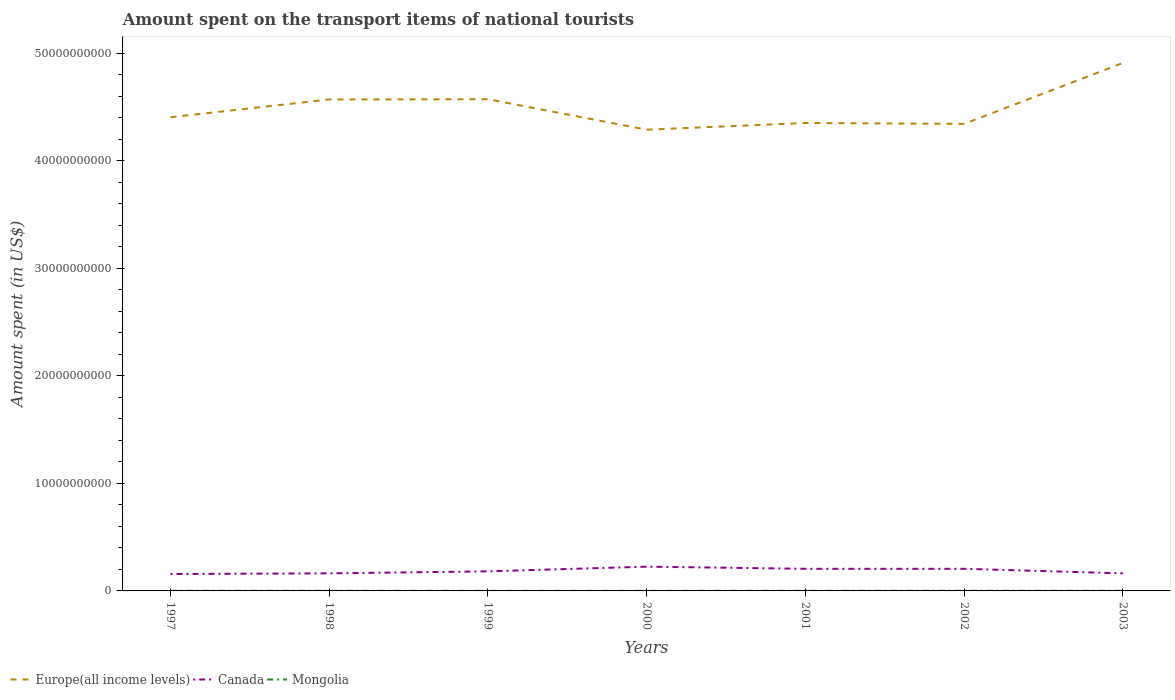Across all years, what is the maximum amount spent on the transport items of national tourists in Canada?
Offer a very short reply. 1.57e+09. In which year was the amount spent on the transport items of national tourists in Canada maximum?
Ensure brevity in your answer.  1997. What is the total amount spent on the transport items of national tourists in Mongolia in the graph?
Offer a very short reply. -3.00e+06. What is the difference between the highest and the second highest amount spent on the transport items of national tourists in Canada?
Keep it short and to the point. 6.86e+08. What is the difference between the highest and the lowest amount spent on the transport items of national tourists in Europe(all income levels)?
Offer a terse response. 3. Is the amount spent on the transport items of national tourists in Canada strictly greater than the amount spent on the transport items of national tourists in Europe(all income levels) over the years?
Provide a short and direct response. Yes. How many lines are there?
Offer a very short reply. 3. What is the difference between two consecutive major ticks on the Y-axis?
Ensure brevity in your answer.  1.00e+1. Are the values on the major ticks of Y-axis written in scientific E-notation?
Offer a terse response. No. Where does the legend appear in the graph?
Your answer should be compact. Bottom left. How many legend labels are there?
Your answer should be very brief. 3. What is the title of the graph?
Offer a very short reply. Amount spent on the transport items of national tourists. What is the label or title of the Y-axis?
Ensure brevity in your answer.  Amount spent (in US$). What is the Amount spent (in US$) of Europe(all income levels) in 1997?
Offer a very short reply. 4.41e+1. What is the Amount spent (in US$) of Canada in 1997?
Make the answer very short. 1.57e+09. What is the Amount spent (in US$) of Europe(all income levels) in 1998?
Give a very brief answer. 4.57e+1. What is the Amount spent (in US$) in Canada in 1998?
Your response must be concise. 1.64e+09. What is the Amount spent (in US$) in Mongolia in 1998?
Your response must be concise. 1.20e+07. What is the Amount spent (in US$) of Europe(all income levels) in 1999?
Ensure brevity in your answer.  4.57e+1. What is the Amount spent (in US$) of Canada in 1999?
Ensure brevity in your answer.  1.82e+09. What is the Amount spent (in US$) of Europe(all income levels) in 2000?
Provide a succinct answer. 4.29e+1. What is the Amount spent (in US$) of Canada in 2000?
Provide a short and direct response. 2.26e+09. What is the Amount spent (in US$) in Mongolia in 2000?
Give a very brief answer. 7.00e+06. What is the Amount spent (in US$) of Europe(all income levels) in 2001?
Offer a very short reply. 4.35e+1. What is the Amount spent (in US$) in Canada in 2001?
Offer a terse response. 2.06e+09. What is the Amount spent (in US$) in Europe(all income levels) in 2002?
Provide a short and direct response. 4.34e+1. What is the Amount spent (in US$) in Canada in 2002?
Make the answer very short. 2.06e+09. What is the Amount spent (in US$) of Mongolia in 2002?
Offer a terse response. 1.30e+07. What is the Amount spent (in US$) of Europe(all income levels) in 2003?
Provide a short and direct response. 4.91e+1. What is the Amount spent (in US$) of Canada in 2003?
Provide a short and direct response. 1.63e+09. What is the Amount spent (in US$) in Mongolia in 2003?
Ensure brevity in your answer.  1.10e+07. Across all years, what is the maximum Amount spent (in US$) in Europe(all income levels)?
Provide a short and direct response. 4.91e+1. Across all years, what is the maximum Amount spent (in US$) in Canada?
Give a very brief answer. 2.26e+09. Across all years, what is the maximum Amount spent (in US$) in Mongolia?
Your response must be concise. 1.30e+07. Across all years, what is the minimum Amount spent (in US$) of Europe(all income levels)?
Ensure brevity in your answer.  4.29e+1. Across all years, what is the minimum Amount spent (in US$) of Canada?
Offer a terse response. 1.57e+09. Across all years, what is the minimum Amount spent (in US$) of Mongolia?
Offer a very short reply. 7.00e+06. What is the total Amount spent (in US$) of Europe(all income levels) in the graph?
Your answer should be very brief. 3.14e+11. What is the total Amount spent (in US$) of Canada in the graph?
Your answer should be very brief. 1.30e+1. What is the total Amount spent (in US$) in Mongolia in the graph?
Provide a short and direct response. 7.20e+07. What is the difference between the Amount spent (in US$) in Europe(all income levels) in 1997 and that in 1998?
Provide a succinct answer. -1.66e+09. What is the difference between the Amount spent (in US$) of Canada in 1997 and that in 1998?
Keep it short and to the point. -6.40e+07. What is the difference between the Amount spent (in US$) of Europe(all income levels) in 1997 and that in 1999?
Make the answer very short. -1.68e+09. What is the difference between the Amount spent (in US$) in Canada in 1997 and that in 1999?
Give a very brief answer. -2.50e+08. What is the difference between the Amount spent (in US$) in Mongolia in 1997 and that in 1999?
Offer a terse response. 5.00e+06. What is the difference between the Amount spent (in US$) in Europe(all income levels) in 1997 and that in 2000?
Your response must be concise. 1.16e+09. What is the difference between the Amount spent (in US$) in Canada in 1997 and that in 2000?
Offer a very short reply. -6.86e+08. What is the difference between the Amount spent (in US$) in Mongolia in 1997 and that in 2000?
Give a very brief answer. 5.00e+06. What is the difference between the Amount spent (in US$) in Europe(all income levels) in 1997 and that in 2001?
Provide a succinct answer. 5.35e+08. What is the difference between the Amount spent (in US$) of Canada in 1997 and that in 2001?
Give a very brief answer. -4.86e+08. What is the difference between the Amount spent (in US$) in Mongolia in 1997 and that in 2001?
Keep it short and to the point. 2.00e+06. What is the difference between the Amount spent (in US$) in Europe(all income levels) in 1997 and that in 2002?
Make the answer very short. 6.14e+08. What is the difference between the Amount spent (in US$) of Canada in 1997 and that in 2002?
Your response must be concise. -4.86e+08. What is the difference between the Amount spent (in US$) of Mongolia in 1997 and that in 2002?
Keep it short and to the point. -1.00e+06. What is the difference between the Amount spent (in US$) in Europe(all income levels) in 1997 and that in 2003?
Keep it short and to the point. -5.05e+09. What is the difference between the Amount spent (in US$) of Canada in 1997 and that in 2003?
Provide a succinct answer. -6.30e+07. What is the difference between the Amount spent (in US$) of Mongolia in 1997 and that in 2003?
Your answer should be compact. 1.00e+06. What is the difference between the Amount spent (in US$) of Europe(all income levels) in 1998 and that in 1999?
Provide a succinct answer. -2.19e+07. What is the difference between the Amount spent (in US$) of Canada in 1998 and that in 1999?
Provide a succinct answer. -1.86e+08. What is the difference between the Amount spent (in US$) of Europe(all income levels) in 1998 and that in 2000?
Provide a short and direct response. 2.81e+09. What is the difference between the Amount spent (in US$) in Canada in 1998 and that in 2000?
Make the answer very short. -6.22e+08. What is the difference between the Amount spent (in US$) in Mongolia in 1998 and that in 2000?
Offer a terse response. 5.00e+06. What is the difference between the Amount spent (in US$) in Europe(all income levels) in 1998 and that in 2001?
Keep it short and to the point. 2.19e+09. What is the difference between the Amount spent (in US$) in Canada in 1998 and that in 2001?
Ensure brevity in your answer.  -4.22e+08. What is the difference between the Amount spent (in US$) of Mongolia in 1998 and that in 2001?
Your answer should be compact. 2.00e+06. What is the difference between the Amount spent (in US$) of Europe(all income levels) in 1998 and that in 2002?
Offer a terse response. 2.27e+09. What is the difference between the Amount spent (in US$) in Canada in 1998 and that in 2002?
Ensure brevity in your answer.  -4.22e+08. What is the difference between the Amount spent (in US$) of Mongolia in 1998 and that in 2002?
Make the answer very short. -1.00e+06. What is the difference between the Amount spent (in US$) of Europe(all income levels) in 1998 and that in 2003?
Provide a short and direct response. -3.39e+09. What is the difference between the Amount spent (in US$) of Mongolia in 1998 and that in 2003?
Your answer should be compact. 1.00e+06. What is the difference between the Amount spent (in US$) in Europe(all income levels) in 1999 and that in 2000?
Offer a very short reply. 2.83e+09. What is the difference between the Amount spent (in US$) in Canada in 1999 and that in 2000?
Provide a short and direct response. -4.36e+08. What is the difference between the Amount spent (in US$) in Mongolia in 1999 and that in 2000?
Provide a succinct answer. 0. What is the difference between the Amount spent (in US$) in Europe(all income levels) in 1999 and that in 2001?
Your answer should be compact. 2.21e+09. What is the difference between the Amount spent (in US$) of Canada in 1999 and that in 2001?
Ensure brevity in your answer.  -2.36e+08. What is the difference between the Amount spent (in US$) of Europe(all income levels) in 1999 and that in 2002?
Your answer should be very brief. 2.29e+09. What is the difference between the Amount spent (in US$) in Canada in 1999 and that in 2002?
Your answer should be compact. -2.36e+08. What is the difference between the Amount spent (in US$) of Mongolia in 1999 and that in 2002?
Make the answer very short. -6.00e+06. What is the difference between the Amount spent (in US$) of Europe(all income levels) in 1999 and that in 2003?
Make the answer very short. -3.37e+09. What is the difference between the Amount spent (in US$) of Canada in 1999 and that in 2003?
Provide a short and direct response. 1.87e+08. What is the difference between the Amount spent (in US$) of Europe(all income levels) in 2000 and that in 2001?
Your response must be concise. -6.21e+08. What is the difference between the Amount spent (in US$) of Mongolia in 2000 and that in 2001?
Ensure brevity in your answer.  -3.00e+06. What is the difference between the Amount spent (in US$) of Europe(all income levels) in 2000 and that in 2002?
Ensure brevity in your answer.  -5.42e+08. What is the difference between the Amount spent (in US$) of Mongolia in 2000 and that in 2002?
Your answer should be very brief. -6.00e+06. What is the difference between the Amount spent (in US$) in Europe(all income levels) in 2000 and that in 2003?
Make the answer very short. -6.21e+09. What is the difference between the Amount spent (in US$) of Canada in 2000 and that in 2003?
Ensure brevity in your answer.  6.23e+08. What is the difference between the Amount spent (in US$) in Europe(all income levels) in 2001 and that in 2002?
Provide a short and direct response. 7.86e+07. What is the difference between the Amount spent (in US$) in Canada in 2001 and that in 2002?
Ensure brevity in your answer.  0. What is the difference between the Amount spent (in US$) of Mongolia in 2001 and that in 2002?
Your answer should be compact. -3.00e+06. What is the difference between the Amount spent (in US$) in Europe(all income levels) in 2001 and that in 2003?
Your answer should be compact. -5.58e+09. What is the difference between the Amount spent (in US$) in Canada in 2001 and that in 2003?
Ensure brevity in your answer.  4.23e+08. What is the difference between the Amount spent (in US$) of Mongolia in 2001 and that in 2003?
Provide a succinct answer. -1.00e+06. What is the difference between the Amount spent (in US$) of Europe(all income levels) in 2002 and that in 2003?
Ensure brevity in your answer.  -5.66e+09. What is the difference between the Amount spent (in US$) of Canada in 2002 and that in 2003?
Offer a terse response. 4.23e+08. What is the difference between the Amount spent (in US$) of Europe(all income levels) in 1997 and the Amount spent (in US$) of Canada in 1998?
Provide a short and direct response. 4.24e+1. What is the difference between the Amount spent (in US$) of Europe(all income levels) in 1997 and the Amount spent (in US$) of Mongolia in 1998?
Keep it short and to the point. 4.40e+1. What is the difference between the Amount spent (in US$) of Canada in 1997 and the Amount spent (in US$) of Mongolia in 1998?
Provide a succinct answer. 1.56e+09. What is the difference between the Amount spent (in US$) in Europe(all income levels) in 1997 and the Amount spent (in US$) in Canada in 1999?
Keep it short and to the point. 4.22e+1. What is the difference between the Amount spent (in US$) of Europe(all income levels) in 1997 and the Amount spent (in US$) of Mongolia in 1999?
Provide a succinct answer. 4.41e+1. What is the difference between the Amount spent (in US$) in Canada in 1997 and the Amount spent (in US$) in Mongolia in 1999?
Your answer should be very brief. 1.56e+09. What is the difference between the Amount spent (in US$) in Europe(all income levels) in 1997 and the Amount spent (in US$) in Canada in 2000?
Offer a very short reply. 4.18e+1. What is the difference between the Amount spent (in US$) in Europe(all income levels) in 1997 and the Amount spent (in US$) in Mongolia in 2000?
Make the answer very short. 4.41e+1. What is the difference between the Amount spent (in US$) of Canada in 1997 and the Amount spent (in US$) of Mongolia in 2000?
Make the answer very short. 1.56e+09. What is the difference between the Amount spent (in US$) of Europe(all income levels) in 1997 and the Amount spent (in US$) of Canada in 2001?
Your response must be concise. 4.20e+1. What is the difference between the Amount spent (in US$) in Europe(all income levels) in 1997 and the Amount spent (in US$) in Mongolia in 2001?
Give a very brief answer. 4.40e+1. What is the difference between the Amount spent (in US$) in Canada in 1997 and the Amount spent (in US$) in Mongolia in 2001?
Make the answer very short. 1.56e+09. What is the difference between the Amount spent (in US$) of Europe(all income levels) in 1997 and the Amount spent (in US$) of Canada in 2002?
Your answer should be compact. 4.20e+1. What is the difference between the Amount spent (in US$) in Europe(all income levels) in 1997 and the Amount spent (in US$) in Mongolia in 2002?
Your response must be concise. 4.40e+1. What is the difference between the Amount spent (in US$) in Canada in 1997 and the Amount spent (in US$) in Mongolia in 2002?
Keep it short and to the point. 1.56e+09. What is the difference between the Amount spent (in US$) in Europe(all income levels) in 1997 and the Amount spent (in US$) in Canada in 2003?
Give a very brief answer. 4.24e+1. What is the difference between the Amount spent (in US$) of Europe(all income levels) in 1997 and the Amount spent (in US$) of Mongolia in 2003?
Offer a terse response. 4.40e+1. What is the difference between the Amount spent (in US$) in Canada in 1997 and the Amount spent (in US$) in Mongolia in 2003?
Keep it short and to the point. 1.56e+09. What is the difference between the Amount spent (in US$) of Europe(all income levels) in 1998 and the Amount spent (in US$) of Canada in 1999?
Your answer should be very brief. 4.39e+1. What is the difference between the Amount spent (in US$) of Europe(all income levels) in 1998 and the Amount spent (in US$) of Mongolia in 1999?
Your response must be concise. 4.57e+1. What is the difference between the Amount spent (in US$) in Canada in 1998 and the Amount spent (in US$) in Mongolia in 1999?
Give a very brief answer. 1.63e+09. What is the difference between the Amount spent (in US$) of Europe(all income levels) in 1998 and the Amount spent (in US$) of Canada in 2000?
Provide a short and direct response. 4.35e+1. What is the difference between the Amount spent (in US$) of Europe(all income levels) in 1998 and the Amount spent (in US$) of Mongolia in 2000?
Make the answer very short. 4.57e+1. What is the difference between the Amount spent (in US$) of Canada in 1998 and the Amount spent (in US$) of Mongolia in 2000?
Provide a short and direct response. 1.63e+09. What is the difference between the Amount spent (in US$) in Europe(all income levels) in 1998 and the Amount spent (in US$) in Canada in 2001?
Your response must be concise. 4.37e+1. What is the difference between the Amount spent (in US$) of Europe(all income levels) in 1998 and the Amount spent (in US$) of Mongolia in 2001?
Provide a succinct answer. 4.57e+1. What is the difference between the Amount spent (in US$) of Canada in 1998 and the Amount spent (in US$) of Mongolia in 2001?
Provide a succinct answer. 1.62e+09. What is the difference between the Amount spent (in US$) of Europe(all income levels) in 1998 and the Amount spent (in US$) of Canada in 2002?
Keep it short and to the point. 4.37e+1. What is the difference between the Amount spent (in US$) of Europe(all income levels) in 1998 and the Amount spent (in US$) of Mongolia in 2002?
Offer a terse response. 4.57e+1. What is the difference between the Amount spent (in US$) in Canada in 1998 and the Amount spent (in US$) in Mongolia in 2002?
Offer a terse response. 1.62e+09. What is the difference between the Amount spent (in US$) in Europe(all income levels) in 1998 and the Amount spent (in US$) in Canada in 2003?
Make the answer very short. 4.41e+1. What is the difference between the Amount spent (in US$) of Europe(all income levels) in 1998 and the Amount spent (in US$) of Mongolia in 2003?
Your answer should be very brief. 4.57e+1. What is the difference between the Amount spent (in US$) in Canada in 1998 and the Amount spent (in US$) in Mongolia in 2003?
Keep it short and to the point. 1.62e+09. What is the difference between the Amount spent (in US$) of Europe(all income levels) in 1999 and the Amount spent (in US$) of Canada in 2000?
Your response must be concise. 4.35e+1. What is the difference between the Amount spent (in US$) of Europe(all income levels) in 1999 and the Amount spent (in US$) of Mongolia in 2000?
Your answer should be compact. 4.57e+1. What is the difference between the Amount spent (in US$) in Canada in 1999 and the Amount spent (in US$) in Mongolia in 2000?
Provide a short and direct response. 1.81e+09. What is the difference between the Amount spent (in US$) in Europe(all income levels) in 1999 and the Amount spent (in US$) in Canada in 2001?
Offer a very short reply. 4.37e+1. What is the difference between the Amount spent (in US$) of Europe(all income levels) in 1999 and the Amount spent (in US$) of Mongolia in 2001?
Offer a very short reply. 4.57e+1. What is the difference between the Amount spent (in US$) of Canada in 1999 and the Amount spent (in US$) of Mongolia in 2001?
Your response must be concise. 1.81e+09. What is the difference between the Amount spent (in US$) of Europe(all income levels) in 1999 and the Amount spent (in US$) of Canada in 2002?
Offer a terse response. 4.37e+1. What is the difference between the Amount spent (in US$) of Europe(all income levels) in 1999 and the Amount spent (in US$) of Mongolia in 2002?
Ensure brevity in your answer.  4.57e+1. What is the difference between the Amount spent (in US$) in Canada in 1999 and the Amount spent (in US$) in Mongolia in 2002?
Give a very brief answer. 1.81e+09. What is the difference between the Amount spent (in US$) in Europe(all income levels) in 1999 and the Amount spent (in US$) in Canada in 2003?
Your answer should be very brief. 4.41e+1. What is the difference between the Amount spent (in US$) of Europe(all income levels) in 1999 and the Amount spent (in US$) of Mongolia in 2003?
Offer a terse response. 4.57e+1. What is the difference between the Amount spent (in US$) of Canada in 1999 and the Amount spent (in US$) of Mongolia in 2003?
Offer a terse response. 1.81e+09. What is the difference between the Amount spent (in US$) in Europe(all income levels) in 2000 and the Amount spent (in US$) in Canada in 2001?
Offer a terse response. 4.08e+1. What is the difference between the Amount spent (in US$) in Europe(all income levels) in 2000 and the Amount spent (in US$) in Mongolia in 2001?
Provide a succinct answer. 4.29e+1. What is the difference between the Amount spent (in US$) of Canada in 2000 and the Amount spent (in US$) of Mongolia in 2001?
Provide a succinct answer. 2.25e+09. What is the difference between the Amount spent (in US$) in Europe(all income levels) in 2000 and the Amount spent (in US$) in Canada in 2002?
Ensure brevity in your answer.  4.08e+1. What is the difference between the Amount spent (in US$) of Europe(all income levels) in 2000 and the Amount spent (in US$) of Mongolia in 2002?
Your response must be concise. 4.29e+1. What is the difference between the Amount spent (in US$) in Canada in 2000 and the Amount spent (in US$) in Mongolia in 2002?
Provide a succinct answer. 2.24e+09. What is the difference between the Amount spent (in US$) in Europe(all income levels) in 2000 and the Amount spent (in US$) in Canada in 2003?
Your answer should be very brief. 4.13e+1. What is the difference between the Amount spent (in US$) of Europe(all income levels) in 2000 and the Amount spent (in US$) of Mongolia in 2003?
Offer a very short reply. 4.29e+1. What is the difference between the Amount spent (in US$) in Canada in 2000 and the Amount spent (in US$) in Mongolia in 2003?
Offer a terse response. 2.25e+09. What is the difference between the Amount spent (in US$) in Europe(all income levels) in 2001 and the Amount spent (in US$) in Canada in 2002?
Give a very brief answer. 4.15e+1. What is the difference between the Amount spent (in US$) in Europe(all income levels) in 2001 and the Amount spent (in US$) in Mongolia in 2002?
Your response must be concise. 4.35e+1. What is the difference between the Amount spent (in US$) in Canada in 2001 and the Amount spent (in US$) in Mongolia in 2002?
Ensure brevity in your answer.  2.04e+09. What is the difference between the Amount spent (in US$) of Europe(all income levels) in 2001 and the Amount spent (in US$) of Canada in 2003?
Give a very brief answer. 4.19e+1. What is the difference between the Amount spent (in US$) in Europe(all income levels) in 2001 and the Amount spent (in US$) in Mongolia in 2003?
Provide a short and direct response. 4.35e+1. What is the difference between the Amount spent (in US$) in Canada in 2001 and the Amount spent (in US$) in Mongolia in 2003?
Ensure brevity in your answer.  2.05e+09. What is the difference between the Amount spent (in US$) of Europe(all income levels) in 2002 and the Amount spent (in US$) of Canada in 2003?
Ensure brevity in your answer.  4.18e+1. What is the difference between the Amount spent (in US$) of Europe(all income levels) in 2002 and the Amount spent (in US$) of Mongolia in 2003?
Offer a very short reply. 4.34e+1. What is the difference between the Amount spent (in US$) of Canada in 2002 and the Amount spent (in US$) of Mongolia in 2003?
Provide a short and direct response. 2.05e+09. What is the average Amount spent (in US$) in Europe(all income levels) per year?
Provide a short and direct response. 4.49e+1. What is the average Amount spent (in US$) of Canada per year?
Provide a succinct answer. 1.86e+09. What is the average Amount spent (in US$) of Mongolia per year?
Ensure brevity in your answer.  1.03e+07. In the year 1997, what is the difference between the Amount spent (in US$) in Europe(all income levels) and Amount spent (in US$) in Canada?
Offer a very short reply. 4.25e+1. In the year 1997, what is the difference between the Amount spent (in US$) in Europe(all income levels) and Amount spent (in US$) in Mongolia?
Provide a short and direct response. 4.40e+1. In the year 1997, what is the difference between the Amount spent (in US$) in Canada and Amount spent (in US$) in Mongolia?
Ensure brevity in your answer.  1.56e+09. In the year 1998, what is the difference between the Amount spent (in US$) in Europe(all income levels) and Amount spent (in US$) in Canada?
Offer a very short reply. 4.41e+1. In the year 1998, what is the difference between the Amount spent (in US$) of Europe(all income levels) and Amount spent (in US$) of Mongolia?
Make the answer very short. 4.57e+1. In the year 1998, what is the difference between the Amount spent (in US$) in Canada and Amount spent (in US$) in Mongolia?
Keep it short and to the point. 1.62e+09. In the year 1999, what is the difference between the Amount spent (in US$) in Europe(all income levels) and Amount spent (in US$) in Canada?
Keep it short and to the point. 4.39e+1. In the year 1999, what is the difference between the Amount spent (in US$) in Europe(all income levels) and Amount spent (in US$) in Mongolia?
Keep it short and to the point. 4.57e+1. In the year 1999, what is the difference between the Amount spent (in US$) in Canada and Amount spent (in US$) in Mongolia?
Your answer should be very brief. 1.81e+09. In the year 2000, what is the difference between the Amount spent (in US$) of Europe(all income levels) and Amount spent (in US$) of Canada?
Provide a succinct answer. 4.06e+1. In the year 2000, what is the difference between the Amount spent (in US$) in Europe(all income levels) and Amount spent (in US$) in Mongolia?
Offer a terse response. 4.29e+1. In the year 2000, what is the difference between the Amount spent (in US$) in Canada and Amount spent (in US$) in Mongolia?
Your answer should be compact. 2.25e+09. In the year 2001, what is the difference between the Amount spent (in US$) of Europe(all income levels) and Amount spent (in US$) of Canada?
Ensure brevity in your answer.  4.15e+1. In the year 2001, what is the difference between the Amount spent (in US$) in Europe(all income levels) and Amount spent (in US$) in Mongolia?
Give a very brief answer. 4.35e+1. In the year 2001, what is the difference between the Amount spent (in US$) of Canada and Amount spent (in US$) of Mongolia?
Ensure brevity in your answer.  2.05e+09. In the year 2002, what is the difference between the Amount spent (in US$) of Europe(all income levels) and Amount spent (in US$) of Canada?
Give a very brief answer. 4.14e+1. In the year 2002, what is the difference between the Amount spent (in US$) in Europe(all income levels) and Amount spent (in US$) in Mongolia?
Your answer should be very brief. 4.34e+1. In the year 2002, what is the difference between the Amount spent (in US$) in Canada and Amount spent (in US$) in Mongolia?
Keep it short and to the point. 2.04e+09. In the year 2003, what is the difference between the Amount spent (in US$) in Europe(all income levels) and Amount spent (in US$) in Canada?
Provide a succinct answer. 4.75e+1. In the year 2003, what is the difference between the Amount spent (in US$) of Europe(all income levels) and Amount spent (in US$) of Mongolia?
Your answer should be very brief. 4.91e+1. In the year 2003, what is the difference between the Amount spent (in US$) in Canada and Amount spent (in US$) in Mongolia?
Ensure brevity in your answer.  1.62e+09. What is the ratio of the Amount spent (in US$) of Europe(all income levels) in 1997 to that in 1998?
Make the answer very short. 0.96. What is the ratio of the Amount spent (in US$) of Canada in 1997 to that in 1998?
Ensure brevity in your answer.  0.96. What is the ratio of the Amount spent (in US$) of Mongolia in 1997 to that in 1998?
Ensure brevity in your answer.  1. What is the ratio of the Amount spent (in US$) in Europe(all income levels) in 1997 to that in 1999?
Ensure brevity in your answer.  0.96. What is the ratio of the Amount spent (in US$) of Canada in 1997 to that in 1999?
Offer a terse response. 0.86. What is the ratio of the Amount spent (in US$) of Mongolia in 1997 to that in 1999?
Your answer should be compact. 1.71. What is the ratio of the Amount spent (in US$) of Europe(all income levels) in 1997 to that in 2000?
Your answer should be compact. 1.03. What is the ratio of the Amount spent (in US$) of Canada in 1997 to that in 2000?
Offer a terse response. 0.7. What is the ratio of the Amount spent (in US$) in Mongolia in 1997 to that in 2000?
Your answer should be very brief. 1.71. What is the ratio of the Amount spent (in US$) of Europe(all income levels) in 1997 to that in 2001?
Offer a terse response. 1.01. What is the ratio of the Amount spent (in US$) in Canada in 1997 to that in 2001?
Offer a very short reply. 0.76. What is the ratio of the Amount spent (in US$) of Mongolia in 1997 to that in 2001?
Give a very brief answer. 1.2. What is the ratio of the Amount spent (in US$) in Europe(all income levels) in 1997 to that in 2002?
Provide a succinct answer. 1.01. What is the ratio of the Amount spent (in US$) in Canada in 1997 to that in 2002?
Give a very brief answer. 0.76. What is the ratio of the Amount spent (in US$) of Europe(all income levels) in 1997 to that in 2003?
Offer a terse response. 0.9. What is the ratio of the Amount spent (in US$) in Canada in 1997 to that in 2003?
Ensure brevity in your answer.  0.96. What is the ratio of the Amount spent (in US$) of Mongolia in 1997 to that in 2003?
Make the answer very short. 1.09. What is the ratio of the Amount spent (in US$) in Europe(all income levels) in 1998 to that in 1999?
Your response must be concise. 1. What is the ratio of the Amount spent (in US$) in Canada in 1998 to that in 1999?
Offer a very short reply. 0.9. What is the ratio of the Amount spent (in US$) of Mongolia in 1998 to that in 1999?
Your response must be concise. 1.71. What is the ratio of the Amount spent (in US$) in Europe(all income levels) in 1998 to that in 2000?
Give a very brief answer. 1.07. What is the ratio of the Amount spent (in US$) in Canada in 1998 to that in 2000?
Provide a short and direct response. 0.72. What is the ratio of the Amount spent (in US$) in Mongolia in 1998 to that in 2000?
Give a very brief answer. 1.71. What is the ratio of the Amount spent (in US$) in Europe(all income levels) in 1998 to that in 2001?
Provide a succinct answer. 1.05. What is the ratio of the Amount spent (in US$) of Canada in 1998 to that in 2001?
Provide a short and direct response. 0.79. What is the ratio of the Amount spent (in US$) in Mongolia in 1998 to that in 2001?
Your answer should be compact. 1.2. What is the ratio of the Amount spent (in US$) of Europe(all income levels) in 1998 to that in 2002?
Ensure brevity in your answer.  1.05. What is the ratio of the Amount spent (in US$) of Canada in 1998 to that in 2002?
Make the answer very short. 0.79. What is the ratio of the Amount spent (in US$) of Europe(all income levels) in 1998 to that in 2003?
Your answer should be very brief. 0.93. What is the ratio of the Amount spent (in US$) in Canada in 1998 to that in 2003?
Keep it short and to the point. 1. What is the ratio of the Amount spent (in US$) in Mongolia in 1998 to that in 2003?
Your answer should be compact. 1.09. What is the ratio of the Amount spent (in US$) in Europe(all income levels) in 1999 to that in 2000?
Keep it short and to the point. 1.07. What is the ratio of the Amount spent (in US$) in Canada in 1999 to that in 2000?
Keep it short and to the point. 0.81. What is the ratio of the Amount spent (in US$) of Mongolia in 1999 to that in 2000?
Your response must be concise. 1. What is the ratio of the Amount spent (in US$) in Europe(all income levels) in 1999 to that in 2001?
Your response must be concise. 1.05. What is the ratio of the Amount spent (in US$) of Canada in 1999 to that in 2001?
Offer a very short reply. 0.89. What is the ratio of the Amount spent (in US$) in Europe(all income levels) in 1999 to that in 2002?
Your response must be concise. 1.05. What is the ratio of the Amount spent (in US$) in Canada in 1999 to that in 2002?
Your response must be concise. 0.89. What is the ratio of the Amount spent (in US$) of Mongolia in 1999 to that in 2002?
Your answer should be compact. 0.54. What is the ratio of the Amount spent (in US$) in Europe(all income levels) in 1999 to that in 2003?
Ensure brevity in your answer.  0.93. What is the ratio of the Amount spent (in US$) of Canada in 1999 to that in 2003?
Keep it short and to the point. 1.11. What is the ratio of the Amount spent (in US$) in Mongolia in 1999 to that in 2003?
Provide a succinct answer. 0.64. What is the ratio of the Amount spent (in US$) in Europe(all income levels) in 2000 to that in 2001?
Offer a terse response. 0.99. What is the ratio of the Amount spent (in US$) of Canada in 2000 to that in 2001?
Your answer should be compact. 1.1. What is the ratio of the Amount spent (in US$) of Mongolia in 2000 to that in 2001?
Your answer should be compact. 0.7. What is the ratio of the Amount spent (in US$) in Europe(all income levels) in 2000 to that in 2002?
Keep it short and to the point. 0.99. What is the ratio of the Amount spent (in US$) in Canada in 2000 to that in 2002?
Make the answer very short. 1.1. What is the ratio of the Amount spent (in US$) of Mongolia in 2000 to that in 2002?
Your answer should be compact. 0.54. What is the ratio of the Amount spent (in US$) of Europe(all income levels) in 2000 to that in 2003?
Keep it short and to the point. 0.87. What is the ratio of the Amount spent (in US$) in Canada in 2000 to that in 2003?
Offer a terse response. 1.38. What is the ratio of the Amount spent (in US$) of Mongolia in 2000 to that in 2003?
Ensure brevity in your answer.  0.64. What is the ratio of the Amount spent (in US$) of Mongolia in 2001 to that in 2002?
Your response must be concise. 0.77. What is the ratio of the Amount spent (in US$) in Europe(all income levels) in 2001 to that in 2003?
Offer a very short reply. 0.89. What is the ratio of the Amount spent (in US$) in Canada in 2001 to that in 2003?
Provide a succinct answer. 1.26. What is the ratio of the Amount spent (in US$) of Europe(all income levels) in 2002 to that in 2003?
Keep it short and to the point. 0.88. What is the ratio of the Amount spent (in US$) of Canada in 2002 to that in 2003?
Your answer should be very brief. 1.26. What is the ratio of the Amount spent (in US$) in Mongolia in 2002 to that in 2003?
Make the answer very short. 1.18. What is the difference between the highest and the second highest Amount spent (in US$) of Europe(all income levels)?
Your response must be concise. 3.37e+09. What is the difference between the highest and the second highest Amount spent (in US$) of Canada?
Your answer should be compact. 2.00e+08. What is the difference between the highest and the lowest Amount spent (in US$) in Europe(all income levels)?
Your answer should be very brief. 6.21e+09. What is the difference between the highest and the lowest Amount spent (in US$) of Canada?
Keep it short and to the point. 6.86e+08. What is the difference between the highest and the lowest Amount spent (in US$) in Mongolia?
Provide a short and direct response. 6.00e+06. 